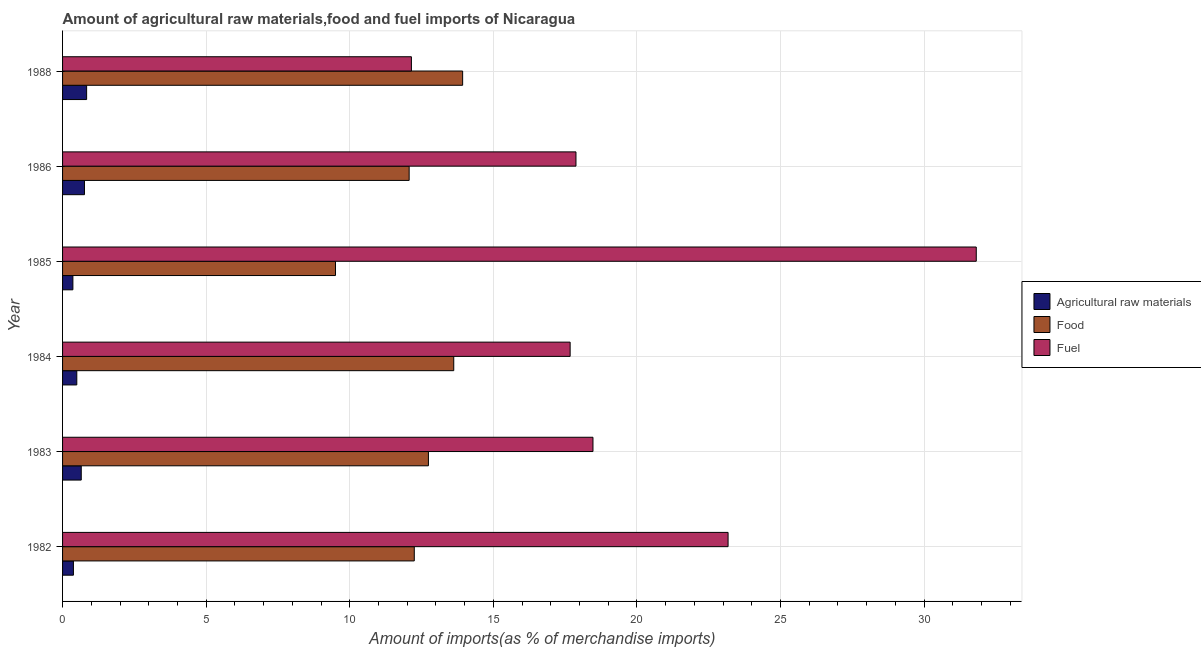How many different coloured bars are there?
Provide a succinct answer. 3. How many bars are there on the 1st tick from the top?
Your answer should be very brief. 3. How many bars are there on the 6th tick from the bottom?
Make the answer very short. 3. What is the percentage of food imports in 1982?
Make the answer very short. 12.25. Across all years, what is the maximum percentage of raw materials imports?
Provide a short and direct response. 0.84. Across all years, what is the minimum percentage of fuel imports?
Keep it short and to the point. 12.15. In which year was the percentage of raw materials imports maximum?
Keep it short and to the point. 1988. What is the total percentage of food imports in the graph?
Your answer should be very brief. 74.11. What is the difference between the percentage of fuel imports in 1983 and that in 1986?
Keep it short and to the point. 0.59. What is the difference between the percentage of raw materials imports in 1985 and the percentage of food imports in 1986?
Provide a short and direct response. -11.71. What is the average percentage of raw materials imports per year?
Keep it short and to the point. 0.58. In the year 1983, what is the difference between the percentage of food imports and percentage of raw materials imports?
Keep it short and to the point. 12.09. In how many years, is the percentage of fuel imports greater than 3 %?
Your response must be concise. 6. What is the ratio of the percentage of raw materials imports in 1985 to that in 1986?
Offer a terse response. 0.47. Is the difference between the percentage of raw materials imports in 1982 and 1985 greater than the difference between the percentage of fuel imports in 1982 and 1985?
Provide a short and direct response. Yes. What is the difference between the highest and the second highest percentage of fuel imports?
Make the answer very short. 8.64. What is the difference between the highest and the lowest percentage of raw materials imports?
Your answer should be compact. 0.48. In how many years, is the percentage of fuel imports greater than the average percentage of fuel imports taken over all years?
Ensure brevity in your answer.  2. What does the 3rd bar from the top in 1984 represents?
Your answer should be compact. Agricultural raw materials. What does the 1st bar from the bottom in 1983 represents?
Your answer should be compact. Agricultural raw materials. Are all the bars in the graph horizontal?
Provide a short and direct response. Yes. How many years are there in the graph?
Give a very brief answer. 6. What is the difference between two consecutive major ticks on the X-axis?
Your answer should be very brief. 5. What is the title of the graph?
Offer a very short reply. Amount of agricultural raw materials,food and fuel imports of Nicaragua. What is the label or title of the X-axis?
Provide a succinct answer. Amount of imports(as % of merchandise imports). What is the Amount of imports(as % of merchandise imports) in Agricultural raw materials in 1982?
Your answer should be compact. 0.38. What is the Amount of imports(as % of merchandise imports) of Food in 1982?
Provide a short and direct response. 12.25. What is the Amount of imports(as % of merchandise imports) of Fuel in 1982?
Your answer should be very brief. 23.17. What is the Amount of imports(as % of merchandise imports) of Agricultural raw materials in 1983?
Provide a succinct answer. 0.65. What is the Amount of imports(as % of merchandise imports) of Food in 1983?
Provide a short and direct response. 12.74. What is the Amount of imports(as % of merchandise imports) of Fuel in 1983?
Give a very brief answer. 18.47. What is the Amount of imports(as % of merchandise imports) in Agricultural raw materials in 1984?
Make the answer very short. 0.5. What is the Amount of imports(as % of merchandise imports) of Food in 1984?
Offer a terse response. 13.62. What is the Amount of imports(as % of merchandise imports) of Fuel in 1984?
Your response must be concise. 17.67. What is the Amount of imports(as % of merchandise imports) in Agricultural raw materials in 1985?
Keep it short and to the point. 0.36. What is the Amount of imports(as % of merchandise imports) in Food in 1985?
Your response must be concise. 9.5. What is the Amount of imports(as % of merchandise imports) in Fuel in 1985?
Provide a succinct answer. 31.82. What is the Amount of imports(as % of merchandise imports) of Agricultural raw materials in 1986?
Provide a short and direct response. 0.76. What is the Amount of imports(as % of merchandise imports) of Food in 1986?
Your response must be concise. 12.07. What is the Amount of imports(as % of merchandise imports) of Fuel in 1986?
Offer a very short reply. 17.88. What is the Amount of imports(as % of merchandise imports) in Agricultural raw materials in 1988?
Your answer should be very brief. 0.84. What is the Amount of imports(as % of merchandise imports) in Food in 1988?
Offer a very short reply. 13.93. What is the Amount of imports(as % of merchandise imports) in Fuel in 1988?
Keep it short and to the point. 12.15. Across all years, what is the maximum Amount of imports(as % of merchandise imports) of Agricultural raw materials?
Offer a very short reply. 0.84. Across all years, what is the maximum Amount of imports(as % of merchandise imports) of Food?
Your answer should be very brief. 13.93. Across all years, what is the maximum Amount of imports(as % of merchandise imports) of Fuel?
Give a very brief answer. 31.82. Across all years, what is the minimum Amount of imports(as % of merchandise imports) in Agricultural raw materials?
Your answer should be compact. 0.36. Across all years, what is the minimum Amount of imports(as % of merchandise imports) of Food?
Offer a very short reply. 9.5. Across all years, what is the minimum Amount of imports(as % of merchandise imports) of Fuel?
Provide a short and direct response. 12.15. What is the total Amount of imports(as % of merchandise imports) in Agricultural raw materials in the graph?
Offer a terse response. 3.48. What is the total Amount of imports(as % of merchandise imports) of Food in the graph?
Provide a succinct answer. 74.11. What is the total Amount of imports(as % of merchandise imports) of Fuel in the graph?
Keep it short and to the point. 121.16. What is the difference between the Amount of imports(as % of merchandise imports) of Agricultural raw materials in 1982 and that in 1983?
Your answer should be compact. -0.27. What is the difference between the Amount of imports(as % of merchandise imports) in Food in 1982 and that in 1983?
Your answer should be very brief. -0.49. What is the difference between the Amount of imports(as % of merchandise imports) of Fuel in 1982 and that in 1983?
Give a very brief answer. 4.7. What is the difference between the Amount of imports(as % of merchandise imports) of Agricultural raw materials in 1982 and that in 1984?
Provide a short and direct response. -0.12. What is the difference between the Amount of imports(as % of merchandise imports) of Food in 1982 and that in 1984?
Offer a very short reply. -1.37. What is the difference between the Amount of imports(as % of merchandise imports) in Fuel in 1982 and that in 1984?
Provide a succinct answer. 5.5. What is the difference between the Amount of imports(as % of merchandise imports) in Agricultural raw materials in 1982 and that in 1985?
Your answer should be very brief. 0.02. What is the difference between the Amount of imports(as % of merchandise imports) in Food in 1982 and that in 1985?
Your answer should be compact. 2.74. What is the difference between the Amount of imports(as % of merchandise imports) in Fuel in 1982 and that in 1985?
Your answer should be very brief. -8.64. What is the difference between the Amount of imports(as % of merchandise imports) of Agricultural raw materials in 1982 and that in 1986?
Make the answer very short. -0.39. What is the difference between the Amount of imports(as % of merchandise imports) in Food in 1982 and that in 1986?
Provide a succinct answer. 0.18. What is the difference between the Amount of imports(as % of merchandise imports) of Fuel in 1982 and that in 1986?
Make the answer very short. 5.3. What is the difference between the Amount of imports(as % of merchandise imports) of Agricultural raw materials in 1982 and that in 1988?
Ensure brevity in your answer.  -0.46. What is the difference between the Amount of imports(as % of merchandise imports) in Food in 1982 and that in 1988?
Your response must be concise. -1.68. What is the difference between the Amount of imports(as % of merchandise imports) of Fuel in 1982 and that in 1988?
Give a very brief answer. 11.03. What is the difference between the Amount of imports(as % of merchandise imports) in Agricultural raw materials in 1983 and that in 1984?
Keep it short and to the point. 0.16. What is the difference between the Amount of imports(as % of merchandise imports) of Food in 1983 and that in 1984?
Your answer should be very brief. -0.88. What is the difference between the Amount of imports(as % of merchandise imports) of Fuel in 1983 and that in 1984?
Make the answer very short. 0.79. What is the difference between the Amount of imports(as % of merchandise imports) of Agricultural raw materials in 1983 and that in 1985?
Your response must be concise. 0.29. What is the difference between the Amount of imports(as % of merchandise imports) in Food in 1983 and that in 1985?
Give a very brief answer. 3.24. What is the difference between the Amount of imports(as % of merchandise imports) in Fuel in 1983 and that in 1985?
Offer a very short reply. -13.35. What is the difference between the Amount of imports(as % of merchandise imports) in Agricultural raw materials in 1983 and that in 1986?
Offer a very short reply. -0.11. What is the difference between the Amount of imports(as % of merchandise imports) in Food in 1983 and that in 1986?
Make the answer very short. 0.67. What is the difference between the Amount of imports(as % of merchandise imports) of Fuel in 1983 and that in 1986?
Ensure brevity in your answer.  0.59. What is the difference between the Amount of imports(as % of merchandise imports) in Agricultural raw materials in 1983 and that in 1988?
Provide a short and direct response. -0.19. What is the difference between the Amount of imports(as % of merchandise imports) in Food in 1983 and that in 1988?
Offer a very short reply. -1.19. What is the difference between the Amount of imports(as % of merchandise imports) in Fuel in 1983 and that in 1988?
Provide a succinct answer. 6.32. What is the difference between the Amount of imports(as % of merchandise imports) of Agricultural raw materials in 1984 and that in 1985?
Offer a terse response. 0.14. What is the difference between the Amount of imports(as % of merchandise imports) of Food in 1984 and that in 1985?
Your answer should be very brief. 4.12. What is the difference between the Amount of imports(as % of merchandise imports) of Fuel in 1984 and that in 1985?
Give a very brief answer. -14.14. What is the difference between the Amount of imports(as % of merchandise imports) of Agricultural raw materials in 1984 and that in 1986?
Offer a very short reply. -0.27. What is the difference between the Amount of imports(as % of merchandise imports) in Food in 1984 and that in 1986?
Your response must be concise. 1.55. What is the difference between the Amount of imports(as % of merchandise imports) in Fuel in 1984 and that in 1986?
Your answer should be very brief. -0.2. What is the difference between the Amount of imports(as % of merchandise imports) in Agricultural raw materials in 1984 and that in 1988?
Offer a terse response. -0.34. What is the difference between the Amount of imports(as % of merchandise imports) of Food in 1984 and that in 1988?
Give a very brief answer. -0.31. What is the difference between the Amount of imports(as % of merchandise imports) in Fuel in 1984 and that in 1988?
Provide a succinct answer. 5.53. What is the difference between the Amount of imports(as % of merchandise imports) in Agricultural raw materials in 1985 and that in 1986?
Offer a very short reply. -0.4. What is the difference between the Amount of imports(as % of merchandise imports) in Food in 1985 and that in 1986?
Provide a short and direct response. -2.57. What is the difference between the Amount of imports(as % of merchandise imports) in Fuel in 1985 and that in 1986?
Provide a short and direct response. 13.94. What is the difference between the Amount of imports(as % of merchandise imports) of Agricultural raw materials in 1985 and that in 1988?
Give a very brief answer. -0.48. What is the difference between the Amount of imports(as % of merchandise imports) of Food in 1985 and that in 1988?
Make the answer very short. -4.43. What is the difference between the Amount of imports(as % of merchandise imports) of Fuel in 1985 and that in 1988?
Make the answer very short. 19.67. What is the difference between the Amount of imports(as % of merchandise imports) of Agricultural raw materials in 1986 and that in 1988?
Keep it short and to the point. -0.07. What is the difference between the Amount of imports(as % of merchandise imports) of Food in 1986 and that in 1988?
Your answer should be very brief. -1.86. What is the difference between the Amount of imports(as % of merchandise imports) in Fuel in 1986 and that in 1988?
Ensure brevity in your answer.  5.73. What is the difference between the Amount of imports(as % of merchandise imports) of Agricultural raw materials in 1982 and the Amount of imports(as % of merchandise imports) of Food in 1983?
Provide a succinct answer. -12.36. What is the difference between the Amount of imports(as % of merchandise imports) in Agricultural raw materials in 1982 and the Amount of imports(as % of merchandise imports) in Fuel in 1983?
Your answer should be compact. -18.09. What is the difference between the Amount of imports(as % of merchandise imports) in Food in 1982 and the Amount of imports(as % of merchandise imports) in Fuel in 1983?
Make the answer very short. -6.22. What is the difference between the Amount of imports(as % of merchandise imports) of Agricultural raw materials in 1982 and the Amount of imports(as % of merchandise imports) of Food in 1984?
Offer a terse response. -13.24. What is the difference between the Amount of imports(as % of merchandise imports) in Agricultural raw materials in 1982 and the Amount of imports(as % of merchandise imports) in Fuel in 1984?
Offer a very short reply. -17.3. What is the difference between the Amount of imports(as % of merchandise imports) in Food in 1982 and the Amount of imports(as % of merchandise imports) in Fuel in 1984?
Provide a short and direct response. -5.43. What is the difference between the Amount of imports(as % of merchandise imports) of Agricultural raw materials in 1982 and the Amount of imports(as % of merchandise imports) of Food in 1985?
Offer a very short reply. -9.13. What is the difference between the Amount of imports(as % of merchandise imports) in Agricultural raw materials in 1982 and the Amount of imports(as % of merchandise imports) in Fuel in 1985?
Give a very brief answer. -31.44. What is the difference between the Amount of imports(as % of merchandise imports) in Food in 1982 and the Amount of imports(as % of merchandise imports) in Fuel in 1985?
Your answer should be very brief. -19.57. What is the difference between the Amount of imports(as % of merchandise imports) in Agricultural raw materials in 1982 and the Amount of imports(as % of merchandise imports) in Food in 1986?
Your response must be concise. -11.69. What is the difference between the Amount of imports(as % of merchandise imports) in Agricultural raw materials in 1982 and the Amount of imports(as % of merchandise imports) in Fuel in 1986?
Offer a very short reply. -17.5. What is the difference between the Amount of imports(as % of merchandise imports) of Food in 1982 and the Amount of imports(as % of merchandise imports) of Fuel in 1986?
Offer a terse response. -5.63. What is the difference between the Amount of imports(as % of merchandise imports) in Agricultural raw materials in 1982 and the Amount of imports(as % of merchandise imports) in Food in 1988?
Provide a succinct answer. -13.55. What is the difference between the Amount of imports(as % of merchandise imports) in Agricultural raw materials in 1982 and the Amount of imports(as % of merchandise imports) in Fuel in 1988?
Give a very brief answer. -11.77. What is the difference between the Amount of imports(as % of merchandise imports) in Food in 1982 and the Amount of imports(as % of merchandise imports) in Fuel in 1988?
Your answer should be very brief. 0.1. What is the difference between the Amount of imports(as % of merchandise imports) of Agricultural raw materials in 1983 and the Amount of imports(as % of merchandise imports) of Food in 1984?
Your response must be concise. -12.97. What is the difference between the Amount of imports(as % of merchandise imports) of Agricultural raw materials in 1983 and the Amount of imports(as % of merchandise imports) of Fuel in 1984?
Give a very brief answer. -17.02. What is the difference between the Amount of imports(as % of merchandise imports) in Food in 1983 and the Amount of imports(as % of merchandise imports) in Fuel in 1984?
Offer a terse response. -4.93. What is the difference between the Amount of imports(as % of merchandise imports) in Agricultural raw materials in 1983 and the Amount of imports(as % of merchandise imports) in Food in 1985?
Offer a very short reply. -8.85. What is the difference between the Amount of imports(as % of merchandise imports) of Agricultural raw materials in 1983 and the Amount of imports(as % of merchandise imports) of Fuel in 1985?
Give a very brief answer. -31.17. What is the difference between the Amount of imports(as % of merchandise imports) of Food in 1983 and the Amount of imports(as % of merchandise imports) of Fuel in 1985?
Give a very brief answer. -19.08. What is the difference between the Amount of imports(as % of merchandise imports) of Agricultural raw materials in 1983 and the Amount of imports(as % of merchandise imports) of Food in 1986?
Offer a very short reply. -11.42. What is the difference between the Amount of imports(as % of merchandise imports) of Agricultural raw materials in 1983 and the Amount of imports(as % of merchandise imports) of Fuel in 1986?
Make the answer very short. -17.23. What is the difference between the Amount of imports(as % of merchandise imports) of Food in 1983 and the Amount of imports(as % of merchandise imports) of Fuel in 1986?
Your answer should be very brief. -5.14. What is the difference between the Amount of imports(as % of merchandise imports) of Agricultural raw materials in 1983 and the Amount of imports(as % of merchandise imports) of Food in 1988?
Make the answer very short. -13.28. What is the difference between the Amount of imports(as % of merchandise imports) of Agricultural raw materials in 1983 and the Amount of imports(as % of merchandise imports) of Fuel in 1988?
Ensure brevity in your answer.  -11.5. What is the difference between the Amount of imports(as % of merchandise imports) in Food in 1983 and the Amount of imports(as % of merchandise imports) in Fuel in 1988?
Keep it short and to the point. 0.59. What is the difference between the Amount of imports(as % of merchandise imports) of Agricultural raw materials in 1984 and the Amount of imports(as % of merchandise imports) of Food in 1985?
Provide a succinct answer. -9.01. What is the difference between the Amount of imports(as % of merchandise imports) of Agricultural raw materials in 1984 and the Amount of imports(as % of merchandise imports) of Fuel in 1985?
Give a very brief answer. -31.32. What is the difference between the Amount of imports(as % of merchandise imports) in Food in 1984 and the Amount of imports(as % of merchandise imports) in Fuel in 1985?
Give a very brief answer. -18.19. What is the difference between the Amount of imports(as % of merchandise imports) in Agricultural raw materials in 1984 and the Amount of imports(as % of merchandise imports) in Food in 1986?
Your answer should be very brief. -11.57. What is the difference between the Amount of imports(as % of merchandise imports) in Agricultural raw materials in 1984 and the Amount of imports(as % of merchandise imports) in Fuel in 1986?
Give a very brief answer. -17.38. What is the difference between the Amount of imports(as % of merchandise imports) of Food in 1984 and the Amount of imports(as % of merchandise imports) of Fuel in 1986?
Provide a succinct answer. -4.26. What is the difference between the Amount of imports(as % of merchandise imports) in Agricultural raw materials in 1984 and the Amount of imports(as % of merchandise imports) in Food in 1988?
Your response must be concise. -13.44. What is the difference between the Amount of imports(as % of merchandise imports) in Agricultural raw materials in 1984 and the Amount of imports(as % of merchandise imports) in Fuel in 1988?
Ensure brevity in your answer.  -11.65. What is the difference between the Amount of imports(as % of merchandise imports) of Food in 1984 and the Amount of imports(as % of merchandise imports) of Fuel in 1988?
Provide a short and direct response. 1.47. What is the difference between the Amount of imports(as % of merchandise imports) in Agricultural raw materials in 1985 and the Amount of imports(as % of merchandise imports) in Food in 1986?
Make the answer very short. -11.71. What is the difference between the Amount of imports(as % of merchandise imports) in Agricultural raw materials in 1985 and the Amount of imports(as % of merchandise imports) in Fuel in 1986?
Your answer should be compact. -17.52. What is the difference between the Amount of imports(as % of merchandise imports) of Food in 1985 and the Amount of imports(as % of merchandise imports) of Fuel in 1986?
Make the answer very short. -8.37. What is the difference between the Amount of imports(as % of merchandise imports) in Agricultural raw materials in 1985 and the Amount of imports(as % of merchandise imports) in Food in 1988?
Offer a very short reply. -13.57. What is the difference between the Amount of imports(as % of merchandise imports) in Agricultural raw materials in 1985 and the Amount of imports(as % of merchandise imports) in Fuel in 1988?
Your answer should be compact. -11.79. What is the difference between the Amount of imports(as % of merchandise imports) in Food in 1985 and the Amount of imports(as % of merchandise imports) in Fuel in 1988?
Give a very brief answer. -2.64. What is the difference between the Amount of imports(as % of merchandise imports) in Agricultural raw materials in 1986 and the Amount of imports(as % of merchandise imports) in Food in 1988?
Provide a short and direct response. -13.17. What is the difference between the Amount of imports(as % of merchandise imports) of Agricultural raw materials in 1986 and the Amount of imports(as % of merchandise imports) of Fuel in 1988?
Give a very brief answer. -11.38. What is the difference between the Amount of imports(as % of merchandise imports) of Food in 1986 and the Amount of imports(as % of merchandise imports) of Fuel in 1988?
Provide a short and direct response. -0.08. What is the average Amount of imports(as % of merchandise imports) of Agricultural raw materials per year?
Ensure brevity in your answer.  0.58. What is the average Amount of imports(as % of merchandise imports) of Food per year?
Offer a very short reply. 12.35. What is the average Amount of imports(as % of merchandise imports) in Fuel per year?
Your answer should be compact. 20.19. In the year 1982, what is the difference between the Amount of imports(as % of merchandise imports) in Agricultural raw materials and Amount of imports(as % of merchandise imports) in Food?
Provide a short and direct response. -11.87. In the year 1982, what is the difference between the Amount of imports(as % of merchandise imports) in Agricultural raw materials and Amount of imports(as % of merchandise imports) in Fuel?
Make the answer very short. -22.8. In the year 1982, what is the difference between the Amount of imports(as % of merchandise imports) of Food and Amount of imports(as % of merchandise imports) of Fuel?
Keep it short and to the point. -10.93. In the year 1983, what is the difference between the Amount of imports(as % of merchandise imports) of Agricultural raw materials and Amount of imports(as % of merchandise imports) of Food?
Your response must be concise. -12.09. In the year 1983, what is the difference between the Amount of imports(as % of merchandise imports) of Agricultural raw materials and Amount of imports(as % of merchandise imports) of Fuel?
Keep it short and to the point. -17.82. In the year 1983, what is the difference between the Amount of imports(as % of merchandise imports) in Food and Amount of imports(as % of merchandise imports) in Fuel?
Your answer should be very brief. -5.73. In the year 1984, what is the difference between the Amount of imports(as % of merchandise imports) of Agricultural raw materials and Amount of imports(as % of merchandise imports) of Food?
Your answer should be compact. -13.13. In the year 1984, what is the difference between the Amount of imports(as % of merchandise imports) in Agricultural raw materials and Amount of imports(as % of merchandise imports) in Fuel?
Offer a very short reply. -17.18. In the year 1984, what is the difference between the Amount of imports(as % of merchandise imports) in Food and Amount of imports(as % of merchandise imports) in Fuel?
Give a very brief answer. -4.05. In the year 1985, what is the difference between the Amount of imports(as % of merchandise imports) of Agricultural raw materials and Amount of imports(as % of merchandise imports) of Food?
Ensure brevity in your answer.  -9.14. In the year 1985, what is the difference between the Amount of imports(as % of merchandise imports) in Agricultural raw materials and Amount of imports(as % of merchandise imports) in Fuel?
Give a very brief answer. -31.46. In the year 1985, what is the difference between the Amount of imports(as % of merchandise imports) in Food and Amount of imports(as % of merchandise imports) in Fuel?
Your answer should be compact. -22.31. In the year 1986, what is the difference between the Amount of imports(as % of merchandise imports) of Agricultural raw materials and Amount of imports(as % of merchandise imports) of Food?
Your response must be concise. -11.31. In the year 1986, what is the difference between the Amount of imports(as % of merchandise imports) of Agricultural raw materials and Amount of imports(as % of merchandise imports) of Fuel?
Offer a terse response. -17.11. In the year 1986, what is the difference between the Amount of imports(as % of merchandise imports) in Food and Amount of imports(as % of merchandise imports) in Fuel?
Provide a succinct answer. -5.81. In the year 1988, what is the difference between the Amount of imports(as % of merchandise imports) of Agricultural raw materials and Amount of imports(as % of merchandise imports) of Food?
Your answer should be compact. -13.09. In the year 1988, what is the difference between the Amount of imports(as % of merchandise imports) in Agricultural raw materials and Amount of imports(as % of merchandise imports) in Fuel?
Offer a terse response. -11.31. In the year 1988, what is the difference between the Amount of imports(as % of merchandise imports) in Food and Amount of imports(as % of merchandise imports) in Fuel?
Offer a very short reply. 1.78. What is the ratio of the Amount of imports(as % of merchandise imports) of Agricultural raw materials in 1982 to that in 1983?
Your answer should be compact. 0.58. What is the ratio of the Amount of imports(as % of merchandise imports) of Food in 1982 to that in 1983?
Your answer should be very brief. 0.96. What is the ratio of the Amount of imports(as % of merchandise imports) of Fuel in 1982 to that in 1983?
Keep it short and to the point. 1.25. What is the ratio of the Amount of imports(as % of merchandise imports) of Agricultural raw materials in 1982 to that in 1984?
Provide a short and direct response. 0.76. What is the ratio of the Amount of imports(as % of merchandise imports) in Food in 1982 to that in 1984?
Ensure brevity in your answer.  0.9. What is the ratio of the Amount of imports(as % of merchandise imports) in Fuel in 1982 to that in 1984?
Offer a very short reply. 1.31. What is the ratio of the Amount of imports(as % of merchandise imports) of Agricultural raw materials in 1982 to that in 1985?
Your answer should be very brief. 1.05. What is the ratio of the Amount of imports(as % of merchandise imports) in Food in 1982 to that in 1985?
Give a very brief answer. 1.29. What is the ratio of the Amount of imports(as % of merchandise imports) of Fuel in 1982 to that in 1985?
Your response must be concise. 0.73. What is the ratio of the Amount of imports(as % of merchandise imports) of Agricultural raw materials in 1982 to that in 1986?
Make the answer very short. 0.5. What is the ratio of the Amount of imports(as % of merchandise imports) in Food in 1982 to that in 1986?
Provide a short and direct response. 1.01. What is the ratio of the Amount of imports(as % of merchandise imports) of Fuel in 1982 to that in 1986?
Keep it short and to the point. 1.3. What is the ratio of the Amount of imports(as % of merchandise imports) in Agricultural raw materials in 1982 to that in 1988?
Your response must be concise. 0.45. What is the ratio of the Amount of imports(as % of merchandise imports) of Food in 1982 to that in 1988?
Ensure brevity in your answer.  0.88. What is the ratio of the Amount of imports(as % of merchandise imports) of Fuel in 1982 to that in 1988?
Provide a succinct answer. 1.91. What is the ratio of the Amount of imports(as % of merchandise imports) of Agricultural raw materials in 1983 to that in 1984?
Offer a terse response. 1.31. What is the ratio of the Amount of imports(as % of merchandise imports) of Food in 1983 to that in 1984?
Give a very brief answer. 0.94. What is the ratio of the Amount of imports(as % of merchandise imports) of Fuel in 1983 to that in 1984?
Provide a short and direct response. 1.04. What is the ratio of the Amount of imports(as % of merchandise imports) of Agricultural raw materials in 1983 to that in 1985?
Give a very brief answer. 1.81. What is the ratio of the Amount of imports(as % of merchandise imports) of Food in 1983 to that in 1985?
Your answer should be compact. 1.34. What is the ratio of the Amount of imports(as % of merchandise imports) in Fuel in 1983 to that in 1985?
Ensure brevity in your answer.  0.58. What is the ratio of the Amount of imports(as % of merchandise imports) in Agricultural raw materials in 1983 to that in 1986?
Your answer should be very brief. 0.85. What is the ratio of the Amount of imports(as % of merchandise imports) in Food in 1983 to that in 1986?
Your answer should be very brief. 1.06. What is the ratio of the Amount of imports(as % of merchandise imports) of Fuel in 1983 to that in 1986?
Provide a short and direct response. 1.03. What is the ratio of the Amount of imports(as % of merchandise imports) of Agricultural raw materials in 1983 to that in 1988?
Your answer should be very brief. 0.78. What is the ratio of the Amount of imports(as % of merchandise imports) in Food in 1983 to that in 1988?
Keep it short and to the point. 0.91. What is the ratio of the Amount of imports(as % of merchandise imports) in Fuel in 1983 to that in 1988?
Make the answer very short. 1.52. What is the ratio of the Amount of imports(as % of merchandise imports) of Agricultural raw materials in 1984 to that in 1985?
Give a very brief answer. 1.38. What is the ratio of the Amount of imports(as % of merchandise imports) in Food in 1984 to that in 1985?
Offer a terse response. 1.43. What is the ratio of the Amount of imports(as % of merchandise imports) of Fuel in 1984 to that in 1985?
Your response must be concise. 0.56. What is the ratio of the Amount of imports(as % of merchandise imports) of Agricultural raw materials in 1984 to that in 1986?
Ensure brevity in your answer.  0.65. What is the ratio of the Amount of imports(as % of merchandise imports) in Food in 1984 to that in 1986?
Give a very brief answer. 1.13. What is the ratio of the Amount of imports(as % of merchandise imports) of Fuel in 1984 to that in 1986?
Provide a short and direct response. 0.99. What is the ratio of the Amount of imports(as % of merchandise imports) in Agricultural raw materials in 1984 to that in 1988?
Your response must be concise. 0.59. What is the ratio of the Amount of imports(as % of merchandise imports) in Food in 1984 to that in 1988?
Give a very brief answer. 0.98. What is the ratio of the Amount of imports(as % of merchandise imports) of Fuel in 1984 to that in 1988?
Your answer should be very brief. 1.46. What is the ratio of the Amount of imports(as % of merchandise imports) of Agricultural raw materials in 1985 to that in 1986?
Give a very brief answer. 0.47. What is the ratio of the Amount of imports(as % of merchandise imports) of Food in 1985 to that in 1986?
Ensure brevity in your answer.  0.79. What is the ratio of the Amount of imports(as % of merchandise imports) in Fuel in 1985 to that in 1986?
Provide a short and direct response. 1.78. What is the ratio of the Amount of imports(as % of merchandise imports) in Agricultural raw materials in 1985 to that in 1988?
Your answer should be compact. 0.43. What is the ratio of the Amount of imports(as % of merchandise imports) in Food in 1985 to that in 1988?
Your answer should be compact. 0.68. What is the ratio of the Amount of imports(as % of merchandise imports) in Fuel in 1985 to that in 1988?
Make the answer very short. 2.62. What is the ratio of the Amount of imports(as % of merchandise imports) in Agricultural raw materials in 1986 to that in 1988?
Your answer should be very brief. 0.91. What is the ratio of the Amount of imports(as % of merchandise imports) of Food in 1986 to that in 1988?
Offer a terse response. 0.87. What is the ratio of the Amount of imports(as % of merchandise imports) of Fuel in 1986 to that in 1988?
Give a very brief answer. 1.47. What is the difference between the highest and the second highest Amount of imports(as % of merchandise imports) of Agricultural raw materials?
Make the answer very short. 0.07. What is the difference between the highest and the second highest Amount of imports(as % of merchandise imports) in Food?
Your response must be concise. 0.31. What is the difference between the highest and the second highest Amount of imports(as % of merchandise imports) in Fuel?
Provide a succinct answer. 8.64. What is the difference between the highest and the lowest Amount of imports(as % of merchandise imports) of Agricultural raw materials?
Keep it short and to the point. 0.48. What is the difference between the highest and the lowest Amount of imports(as % of merchandise imports) of Food?
Provide a succinct answer. 4.43. What is the difference between the highest and the lowest Amount of imports(as % of merchandise imports) in Fuel?
Your response must be concise. 19.67. 